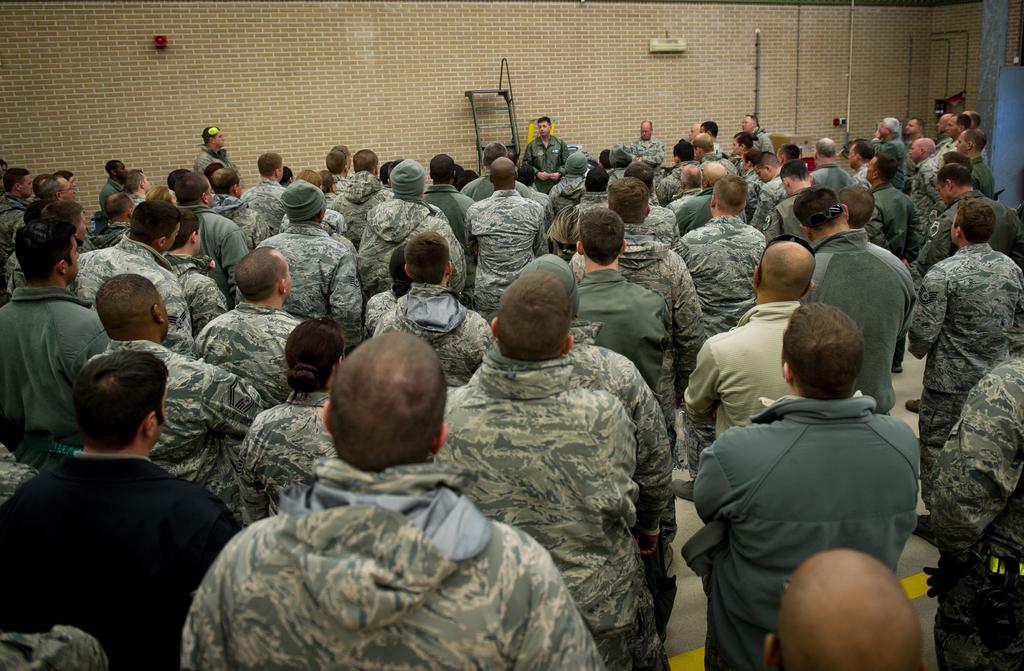Please provide a concise description of this image. In this picture we can observe many men standing in this room. In the background there is a wall which is in cream color. 